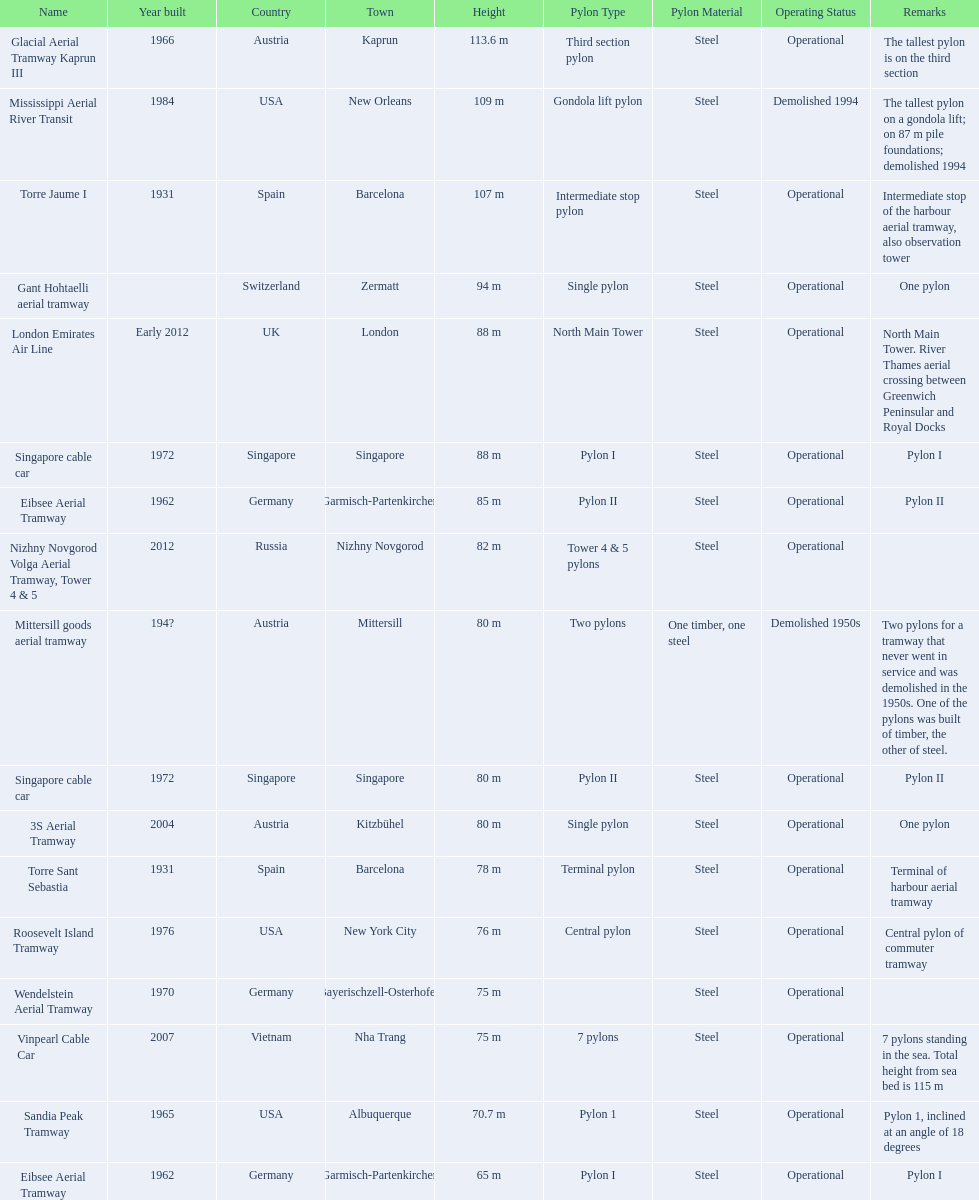What year was the last pylon in germany built? 1970. Help me parse the entirety of this table. {'header': ['Name', 'Year built', 'Country', 'Town', 'Height', 'Pylon Type', 'Pylon Material', 'Operating Status', 'Remarks'], 'rows': [['Glacial Aerial Tramway Kaprun III', '1966', 'Austria', 'Kaprun', '113.6 m', 'Third section pylon', 'Steel', 'Operational', 'The tallest pylon is on the third section'], ['Mississippi Aerial River Transit', '1984', 'USA', 'New Orleans', '109 m', 'Gondola lift pylon', 'Steel', 'Demolished 1994', 'The tallest pylon on a gondola lift; on 87 m pile foundations; demolished 1994'], ['Torre Jaume I', '1931', 'Spain', 'Barcelona', '107 m', 'Intermediate stop pylon', 'Steel', 'Operational', 'Intermediate stop of the harbour aerial tramway, also observation tower'], ['Gant Hohtaelli aerial tramway', '', 'Switzerland', 'Zermatt', '94 m', 'Single pylon', 'Steel', 'Operational', 'One pylon'], ['London Emirates Air Line', 'Early 2012', 'UK', 'London', '88 m', 'North Main Tower', 'Steel', 'Operational', 'North Main Tower. River Thames aerial crossing between Greenwich Peninsular and Royal Docks'], ['Singapore cable car', '1972', 'Singapore', 'Singapore', '88 m', 'Pylon I', 'Steel', 'Operational', 'Pylon I'], ['Eibsee Aerial Tramway', '1962', 'Germany', 'Garmisch-Partenkirchen', '85 m', 'Pylon II', 'Steel', 'Operational', 'Pylon II'], ['Nizhny Novgorod Volga Aerial Tramway, Tower 4 & 5', '2012', 'Russia', 'Nizhny Novgorod', '82 m', 'Tower 4 & 5 pylons', 'Steel', 'Operational', ''], ['Mittersill goods aerial tramway', '194?', 'Austria', 'Mittersill', '80 m', 'Two pylons', 'One timber, one steel', 'Demolished 1950s', 'Two pylons for a tramway that never went in service and was demolished in the 1950s. One of the pylons was built of timber, the other of steel.'], ['Singapore cable car', '1972', 'Singapore', 'Singapore', '80 m', 'Pylon II', 'Steel', 'Operational', 'Pylon II'], ['3S Aerial Tramway', '2004', 'Austria', 'Kitzbühel', '80 m', 'Single pylon', 'Steel', 'Operational', 'One pylon'], ['Torre Sant Sebastia', '1931', 'Spain', 'Barcelona', '78 m', 'Terminal pylon', 'Steel', 'Operational', 'Terminal of harbour aerial tramway'], ['Roosevelt Island Tramway', '1976', 'USA', 'New York City', '76 m', 'Central pylon', 'Steel', 'Operational', 'Central pylon of commuter tramway'], ['Wendelstein Aerial Tramway', '1970', 'Germany', 'Bayerischzell-Osterhofen', '75 m', '', 'Steel', 'Operational', ''], ['Vinpearl Cable Car', '2007', 'Vietnam', 'Nha Trang', '75 m', '7 pylons', 'Steel', 'Operational', '7 pylons standing in the sea. Total height from sea bed is 115 m'], ['Sandia Peak Tramway', '1965', 'USA', 'Albuquerque', '70.7 m', 'Pylon 1', 'Steel', 'Operational', 'Pylon 1, inclined at an angle of 18 degrees'], ['Eibsee Aerial Tramway', '1962', 'Germany', 'Garmisch-Partenkirchen', '65 m', 'Pylon I', 'Steel', 'Operational', 'Pylon I']]} 